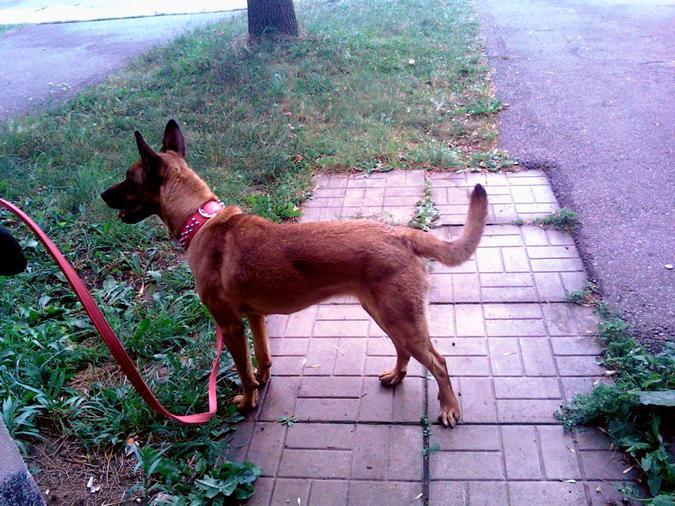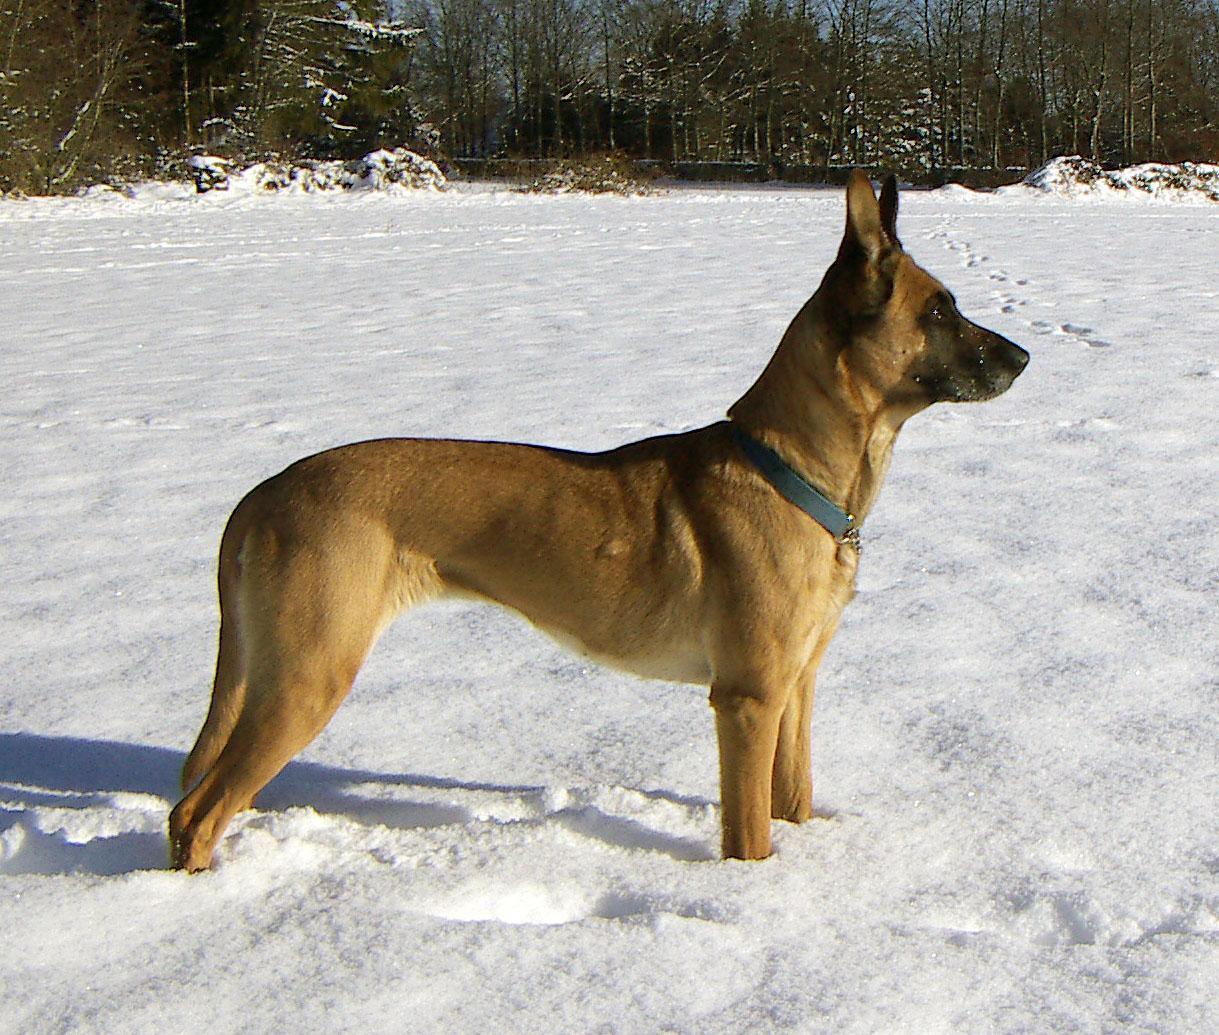The first image is the image on the left, the second image is the image on the right. Examine the images to the left and right. Is the description "black german shepards are oposite each other" accurate? Answer yes or no. No. The first image is the image on the left, the second image is the image on the right. Analyze the images presented: Is the assertion "The picture focuses on the front of the of young tan puppies with black noses." valid? Answer yes or no. No. 